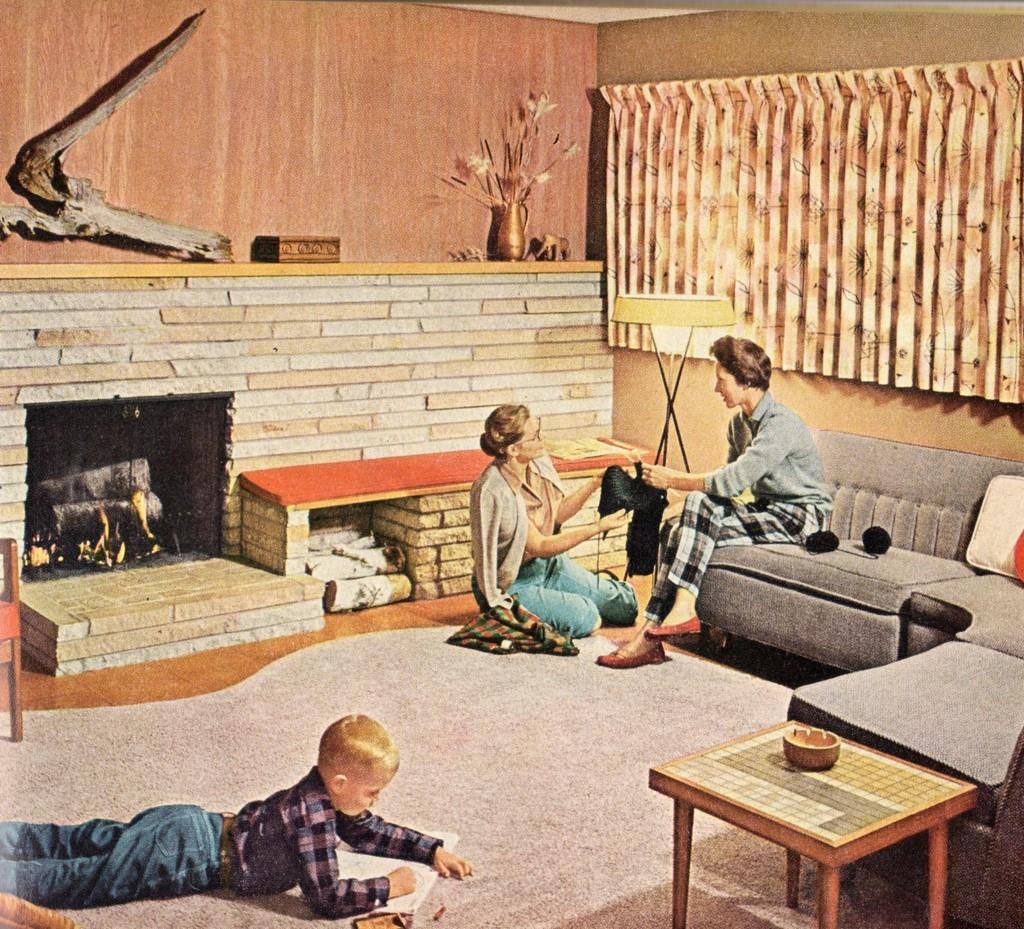Can you describe this image briefly? There is a child lying on the floor he is looking into the book. there is a fireplace on the left side of the image. there is a flower vase. Here the women is sitting on the floor and handing a cloth to the woman who is sitting on the sofa. There is a table placed on the right side of the image. There is also the curtains placed on the right side of the image. Here there is a lamp. 